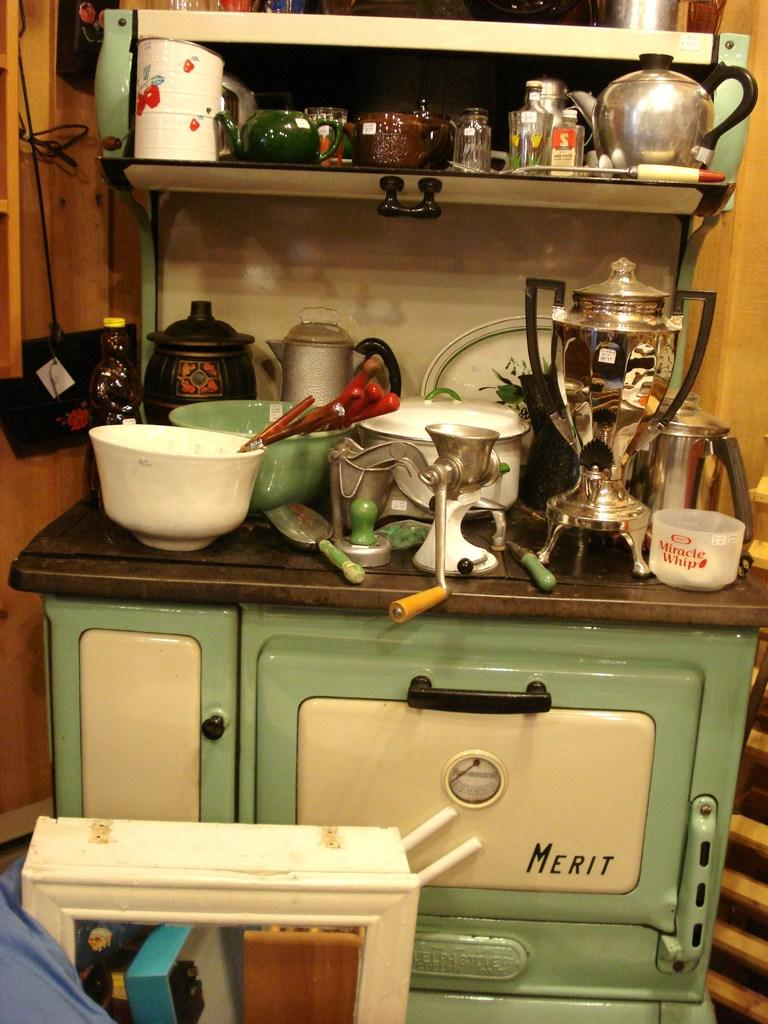<image>
Share a concise interpretation of the image provided. A Merit cabinet with dishes and pans sitting on top of it. 